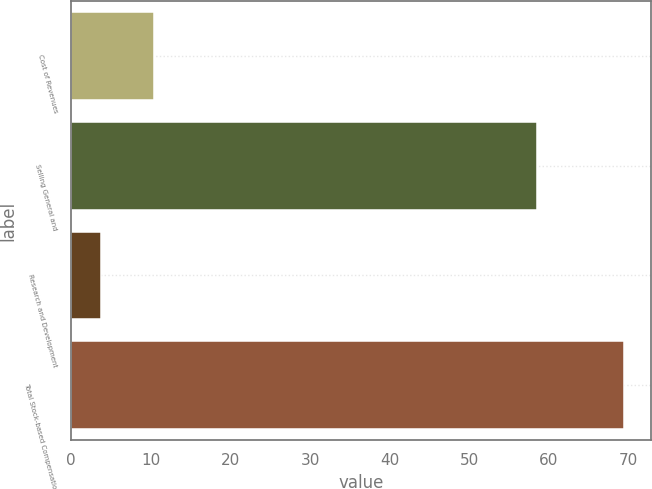<chart> <loc_0><loc_0><loc_500><loc_500><bar_chart><fcel>Cost of Revenues<fcel>Selling General and<fcel>Research and Development<fcel>Total Stock-based Compensation<nl><fcel>10.36<fcel>58.5<fcel>3.8<fcel>69.4<nl></chart> 